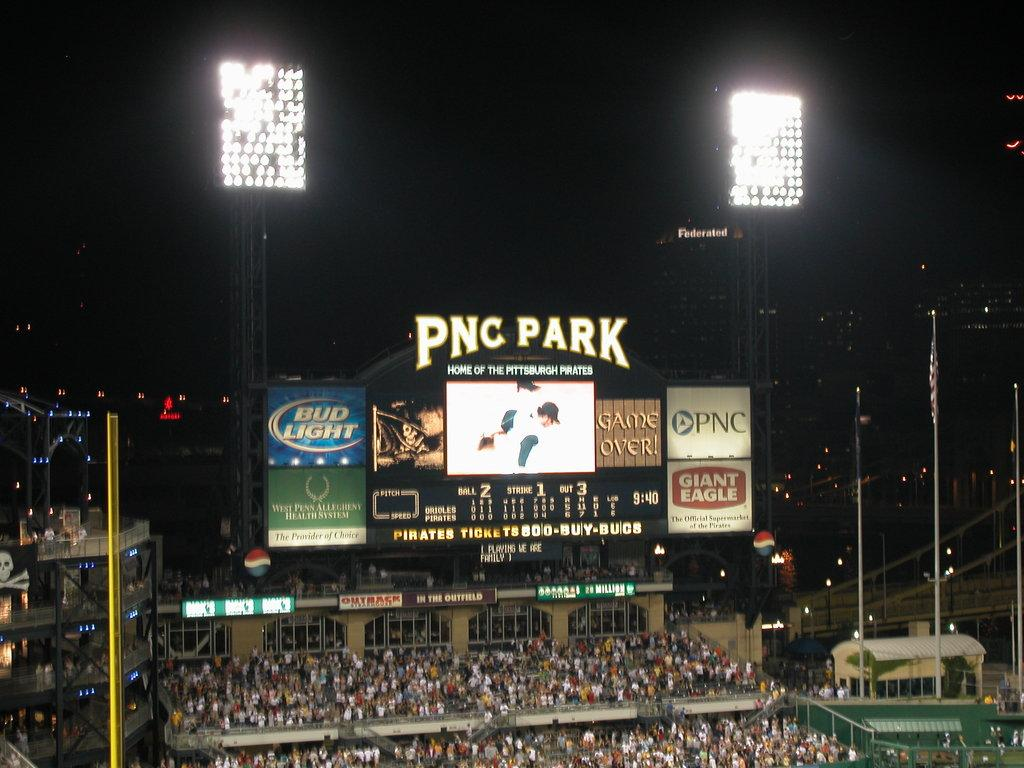<image>
Relay a brief, clear account of the picture shown. A scoreboard at PNC Park sponsored by PNC and Bud Light. 